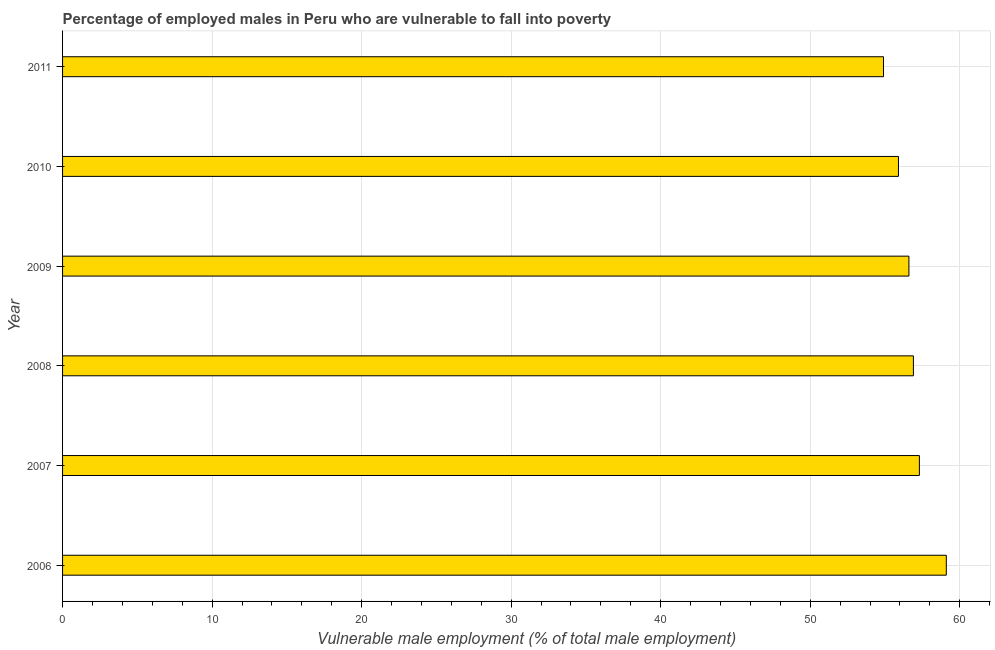What is the title of the graph?
Offer a terse response. Percentage of employed males in Peru who are vulnerable to fall into poverty. What is the label or title of the X-axis?
Your response must be concise. Vulnerable male employment (% of total male employment). What is the label or title of the Y-axis?
Offer a terse response. Year. What is the percentage of employed males who are vulnerable to fall into poverty in 2010?
Provide a succinct answer. 55.9. Across all years, what is the maximum percentage of employed males who are vulnerable to fall into poverty?
Your response must be concise. 59.1. Across all years, what is the minimum percentage of employed males who are vulnerable to fall into poverty?
Your answer should be very brief. 54.9. What is the sum of the percentage of employed males who are vulnerable to fall into poverty?
Provide a short and direct response. 340.7. What is the difference between the percentage of employed males who are vulnerable to fall into poverty in 2008 and 2009?
Ensure brevity in your answer.  0.3. What is the average percentage of employed males who are vulnerable to fall into poverty per year?
Keep it short and to the point. 56.78. What is the median percentage of employed males who are vulnerable to fall into poverty?
Provide a short and direct response. 56.75. What is the ratio of the percentage of employed males who are vulnerable to fall into poverty in 2006 to that in 2011?
Your answer should be very brief. 1.08. Is the percentage of employed males who are vulnerable to fall into poverty in 2006 less than that in 2010?
Offer a very short reply. No. Is the difference between the percentage of employed males who are vulnerable to fall into poverty in 2006 and 2011 greater than the difference between any two years?
Offer a very short reply. Yes. What is the difference between the highest and the second highest percentage of employed males who are vulnerable to fall into poverty?
Make the answer very short. 1.8. In how many years, is the percentage of employed males who are vulnerable to fall into poverty greater than the average percentage of employed males who are vulnerable to fall into poverty taken over all years?
Your answer should be compact. 3. Are all the bars in the graph horizontal?
Provide a succinct answer. Yes. What is the difference between two consecutive major ticks on the X-axis?
Give a very brief answer. 10. Are the values on the major ticks of X-axis written in scientific E-notation?
Your answer should be very brief. No. What is the Vulnerable male employment (% of total male employment) in 2006?
Give a very brief answer. 59.1. What is the Vulnerable male employment (% of total male employment) of 2007?
Make the answer very short. 57.3. What is the Vulnerable male employment (% of total male employment) of 2008?
Provide a short and direct response. 56.9. What is the Vulnerable male employment (% of total male employment) in 2009?
Give a very brief answer. 56.6. What is the Vulnerable male employment (% of total male employment) of 2010?
Provide a succinct answer. 55.9. What is the Vulnerable male employment (% of total male employment) of 2011?
Offer a very short reply. 54.9. What is the difference between the Vulnerable male employment (% of total male employment) in 2006 and 2009?
Give a very brief answer. 2.5. What is the difference between the Vulnerable male employment (% of total male employment) in 2007 and 2008?
Make the answer very short. 0.4. What is the difference between the Vulnerable male employment (% of total male employment) in 2007 and 2010?
Your answer should be very brief. 1.4. What is the difference between the Vulnerable male employment (% of total male employment) in 2008 and 2009?
Provide a succinct answer. 0.3. What is the difference between the Vulnerable male employment (% of total male employment) in 2008 and 2010?
Offer a terse response. 1. What is the difference between the Vulnerable male employment (% of total male employment) in 2009 and 2010?
Make the answer very short. 0.7. What is the difference between the Vulnerable male employment (% of total male employment) in 2010 and 2011?
Provide a short and direct response. 1. What is the ratio of the Vulnerable male employment (% of total male employment) in 2006 to that in 2007?
Give a very brief answer. 1.03. What is the ratio of the Vulnerable male employment (% of total male employment) in 2006 to that in 2008?
Provide a short and direct response. 1.04. What is the ratio of the Vulnerable male employment (% of total male employment) in 2006 to that in 2009?
Provide a short and direct response. 1.04. What is the ratio of the Vulnerable male employment (% of total male employment) in 2006 to that in 2010?
Offer a very short reply. 1.06. What is the ratio of the Vulnerable male employment (% of total male employment) in 2006 to that in 2011?
Keep it short and to the point. 1.08. What is the ratio of the Vulnerable male employment (% of total male employment) in 2007 to that in 2008?
Offer a terse response. 1.01. What is the ratio of the Vulnerable male employment (% of total male employment) in 2007 to that in 2011?
Keep it short and to the point. 1.04. What is the ratio of the Vulnerable male employment (% of total male employment) in 2008 to that in 2010?
Give a very brief answer. 1.02. What is the ratio of the Vulnerable male employment (% of total male employment) in 2008 to that in 2011?
Offer a very short reply. 1.04. What is the ratio of the Vulnerable male employment (% of total male employment) in 2009 to that in 2010?
Offer a very short reply. 1.01. What is the ratio of the Vulnerable male employment (% of total male employment) in 2009 to that in 2011?
Offer a very short reply. 1.03. 